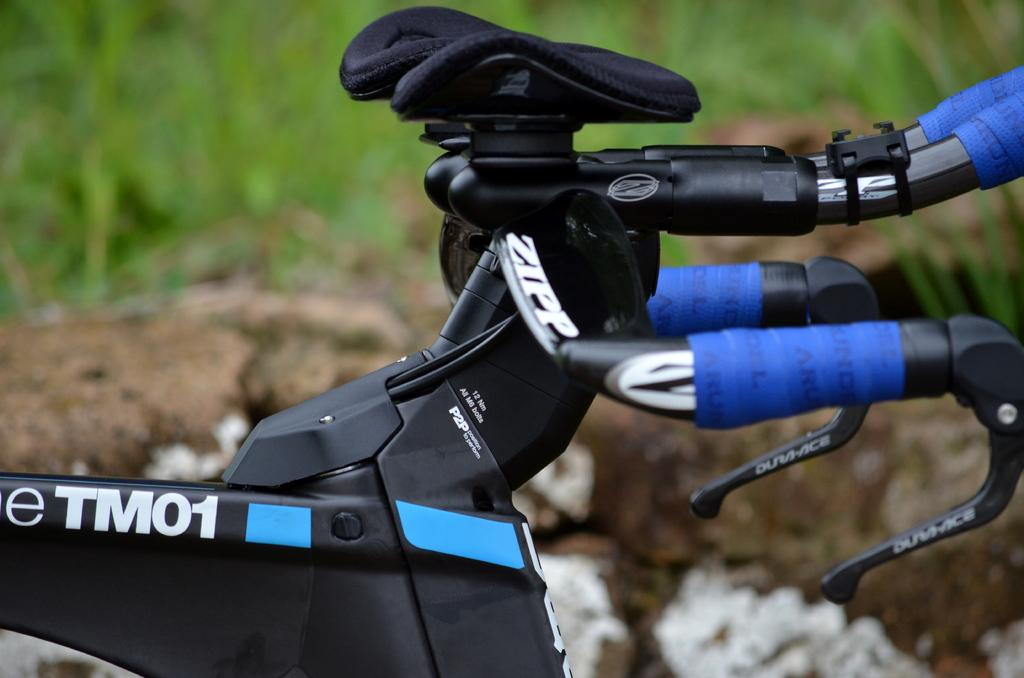What is the main subject in the center of the image? There is a cycle in the center of the image. What type of natural environment is visible in the background of the image? There is grass visible in the background of the image. Can you see a tiger wearing a suit in the image? No, there is no tiger or suit present in the image. Is the grass covered in sleet in the image? The provided facts do not mention any weather conditions, so it cannot be determined if the grass is covered in sleet. 